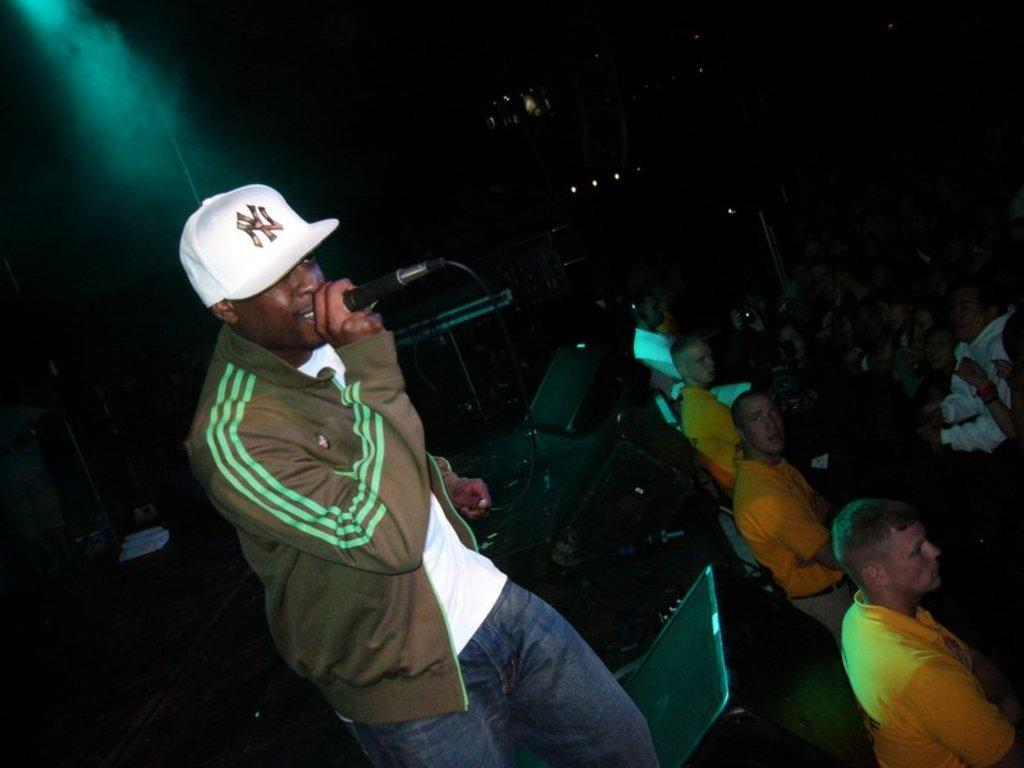What is the man on the left side of the image doing? The man is standing on the left side of the image and holding a mic in his hand. What objects are at the bottom of the image? There are speakers at the bottom of the image. What can be seen on the right side of the image? There is a crowd on the right side of the image. What is visible at the top of the image? There are lights at the top of the image. What type of boot is being served for dinner in the image? There is no boot or dinner present in the image; it features a man holding a mic, speakers, a crowd, and lights. How many pairs of shoes can be seen on the man's feet in the image? There is only one man in the image, and he is not wearing any shoes. 